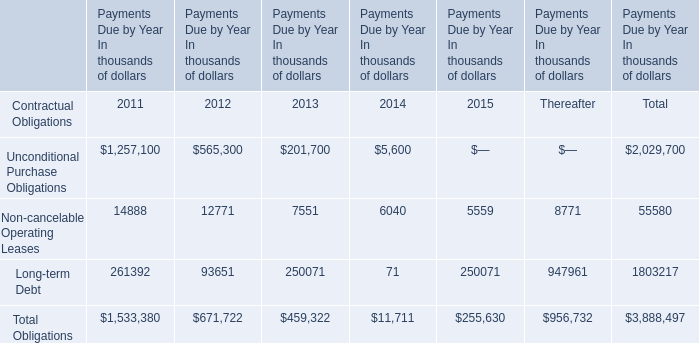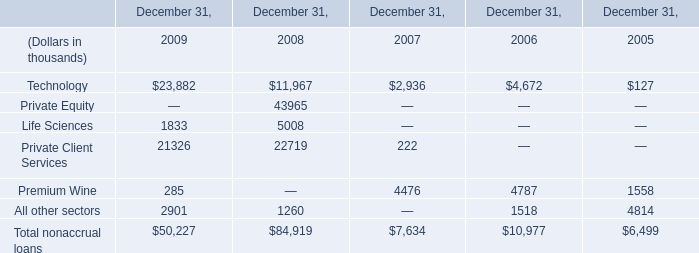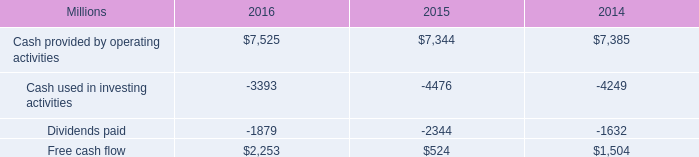What's the sum of Private Client Services of December 31, 2008, and Free cash flow of 2016 ? 
Computations: (22719.0 + 2253.0)
Answer: 24972.0. 